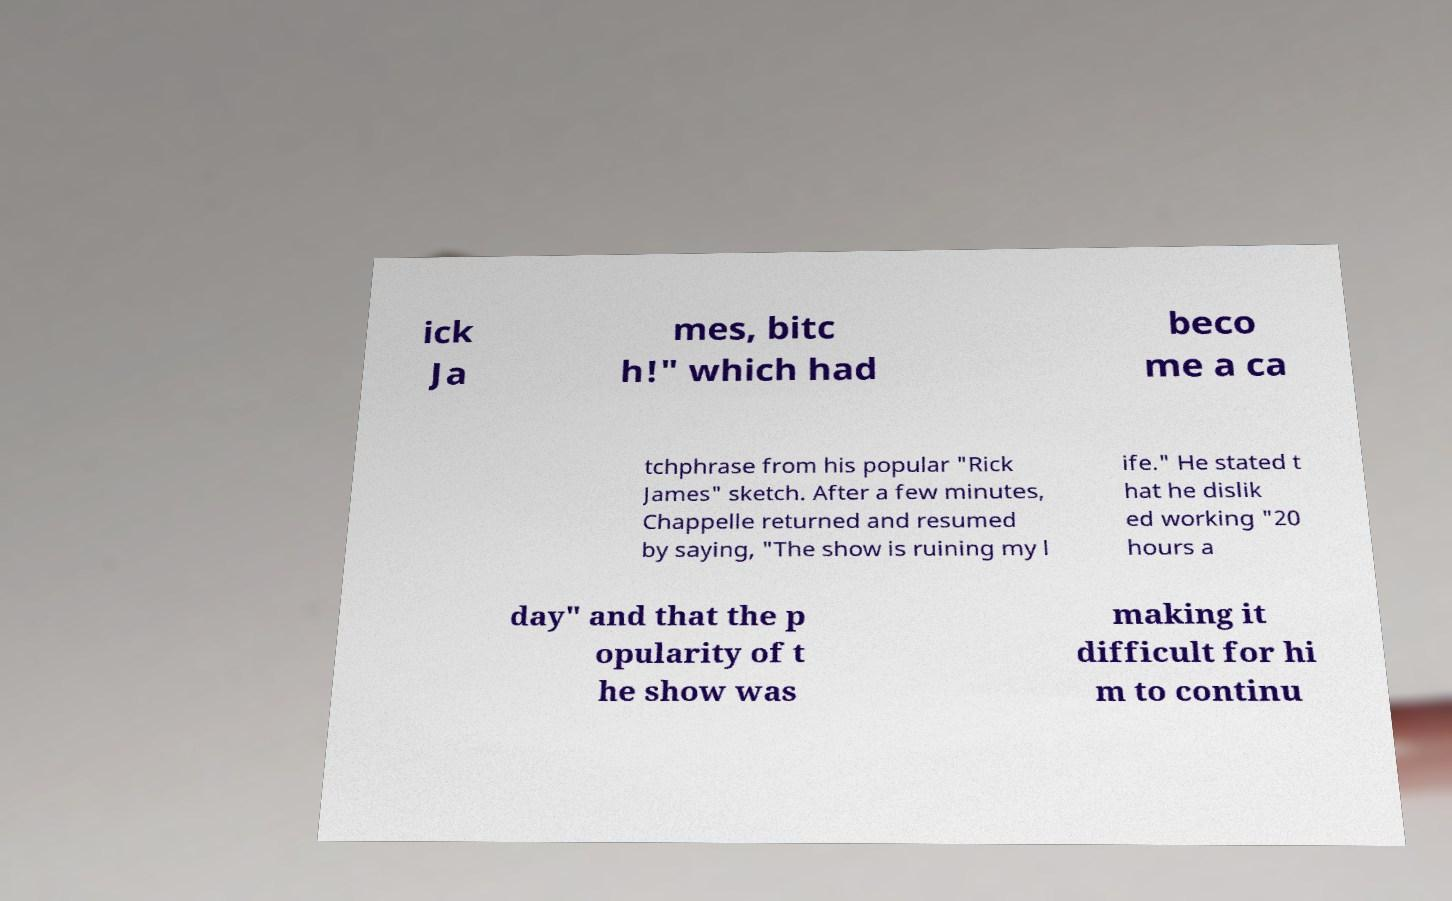Please identify and transcribe the text found in this image. ick Ja mes, bitc h!" which had beco me a ca tchphrase from his popular "Rick James" sketch. After a few minutes, Chappelle returned and resumed by saying, "The show is ruining my l ife." He stated t hat he dislik ed working "20 hours a day" and that the p opularity of t he show was making it difficult for hi m to continu 